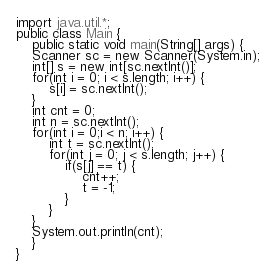<code> <loc_0><loc_0><loc_500><loc_500><_Java_>import java.util.*;
public class Main {
	public static void main(String[] args) {
	Scanner sc = new Scanner(System.in);
	int[] s = new int[sc.nextInt()];
	for(int i = 0; i < s.length; i++) {
		s[i] = sc.nextInt();
	}
	int cnt = 0;
	int n = sc.nextInt();
	for(int i = 0;i < n; i++) {
		int t = sc.nextInt();
		for(int j = 0; j < s.length; j++) {
			if(s[j] == t) {
				cnt++;
				t = -1;
			}
		}
	}
	System.out.println(cnt);
	}
}</code> 